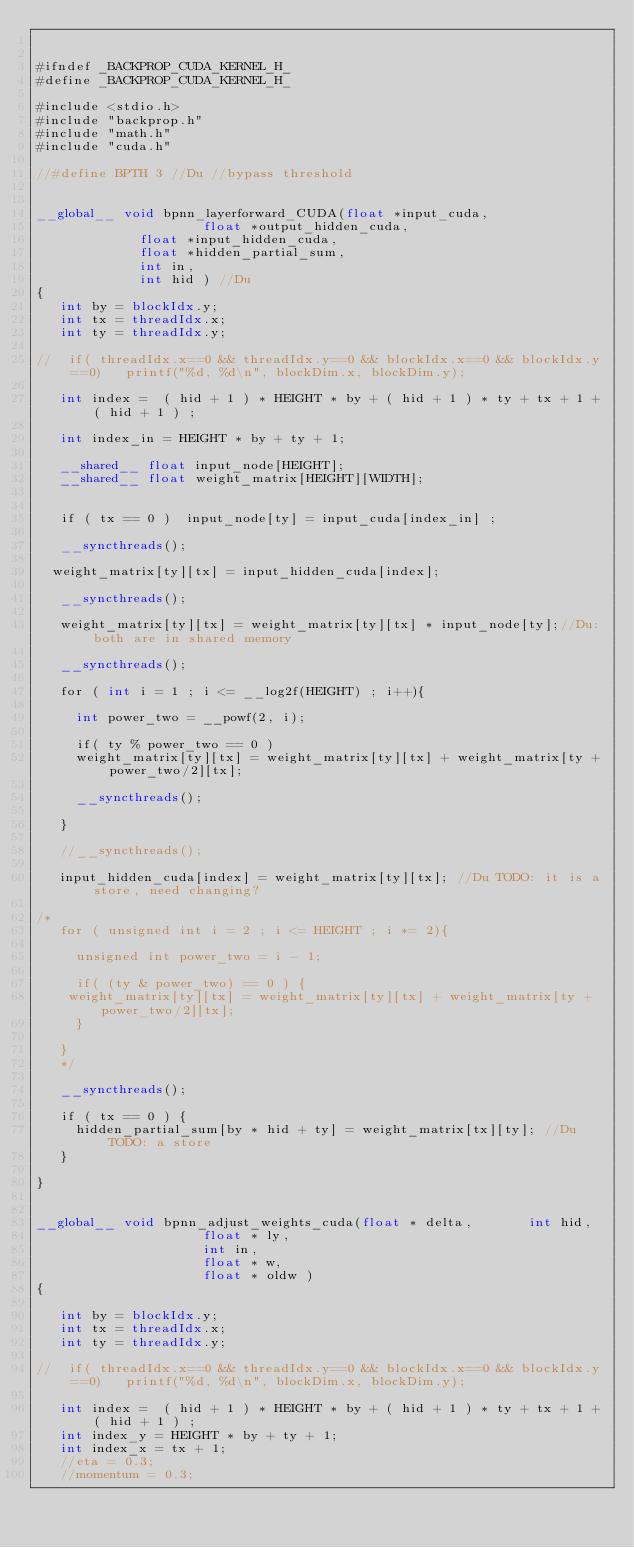<code> <loc_0><loc_0><loc_500><loc_500><_Cuda_>

#ifndef _BACKPROP_CUDA_KERNEL_H_
#define _BACKPROP_CUDA_KERNEL_H_

#include <stdio.h>
#include "backprop.h"
#include "math.h"
#include "cuda.h"

//#define BPTH 3 //Du //bypass threshold


__global__ void bpnn_layerforward_CUDA(float *input_cuda,
	                   float *output_hidden_cuda,
					   float *input_hidden_cuda,
					   float *hidden_partial_sum,
					   int in,
					   int hid ) //Du
{
   int by = blockIdx.y;
   int tx = threadIdx.x;
   int ty = threadIdx.y;

//	if( threadIdx.x==0 && threadIdx.y==0 && blockIdx.x==0 && blockIdx.y==0) 	printf("%d, %d\n", blockDim.x, blockDim.y);

   int index =  ( hid + 1 ) * HEIGHT * by + ( hid + 1 ) * ty + tx + 1 + ( hid + 1 ) ;  

   int index_in = HEIGHT * by + ty + 1;
   
   __shared__ float input_node[HEIGHT];
   __shared__ float weight_matrix[HEIGHT][WIDTH];


   if ( tx == 0 )  input_node[ty] = input_cuda[index_in] ;
   
   __syncthreads();

 	weight_matrix[ty][tx] = input_hidden_cuda[index];

   __syncthreads();
   
   weight_matrix[ty][tx] = weight_matrix[ty][tx] * input_node[ty];//Du: both are in shared memory

   __syncthreads();   
   
   for ( int i = 1 ; i <= __log2f(HEIGHT) ; i++){
 
	   int power_two = __powf(2, i);

	   if( ty % power_two == 0 )
	   weight_matrix[ty][tx] = weight_matrix[ty][tx] + weight_matrix[ty + power_two/2][tx];

	   __syncthreads();

   }
   
   //__syncthreads();

   input_hidden_cuda[index] = weight_matrix[ty][tx]; //Du TODO: it is a store, need changing?
   
/*
   for ( unsigned int i = 2 ; i <= HEIGHT ; i *= 2){
 
	   unsigned int power_two = i - 1;

	   if( (ty & power_two) == 0 ) {
		weight_matrix[ty][tx] = weight_matrix[ty][tx] + weight_matrix[ty + power_two/2][tx];
	   }

   }
   */

   __syncthreads();

   if ( tx == 0 ) {
	   hidden_partial_sum[by * hid + ty] = weight_matrix[tx][ty]; //Du TODO: a store
   }

}


__global__ void bpnn_adjust_weights_cuda(float * delta,  		 	int hid,         
										 float * ly,      
										 int in,          
										 float * w,       
										 float * oldw )  
{
  
   int by = blockIdx.y;
   int tx = threadIdx.x;
   int ty = threadIdx.y;
	
//	if( threadIdx.x==0 && threadIdx.y==0 && blockIdx.x==0 && blockIdx.y==0) 	printf("%d, %d\n", blockDim.x, blockDim.y);
	
   int index =  ( hid + 1 ) * HEIGHT * by + ( hid + 1 ) * ty + tx + 1 + ( hid + 1 ) ;  
   int index_y = HEIGHT * by + ty + 1;
   int index_x = tx + 1;
   //eta = 0.3;
   //momentum = 0.3;
</code> 